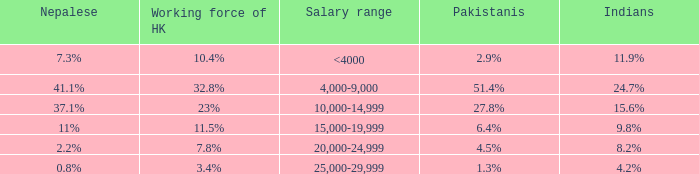If the Indians are 8.2%, what is the salary range? 20,000-24,999. 